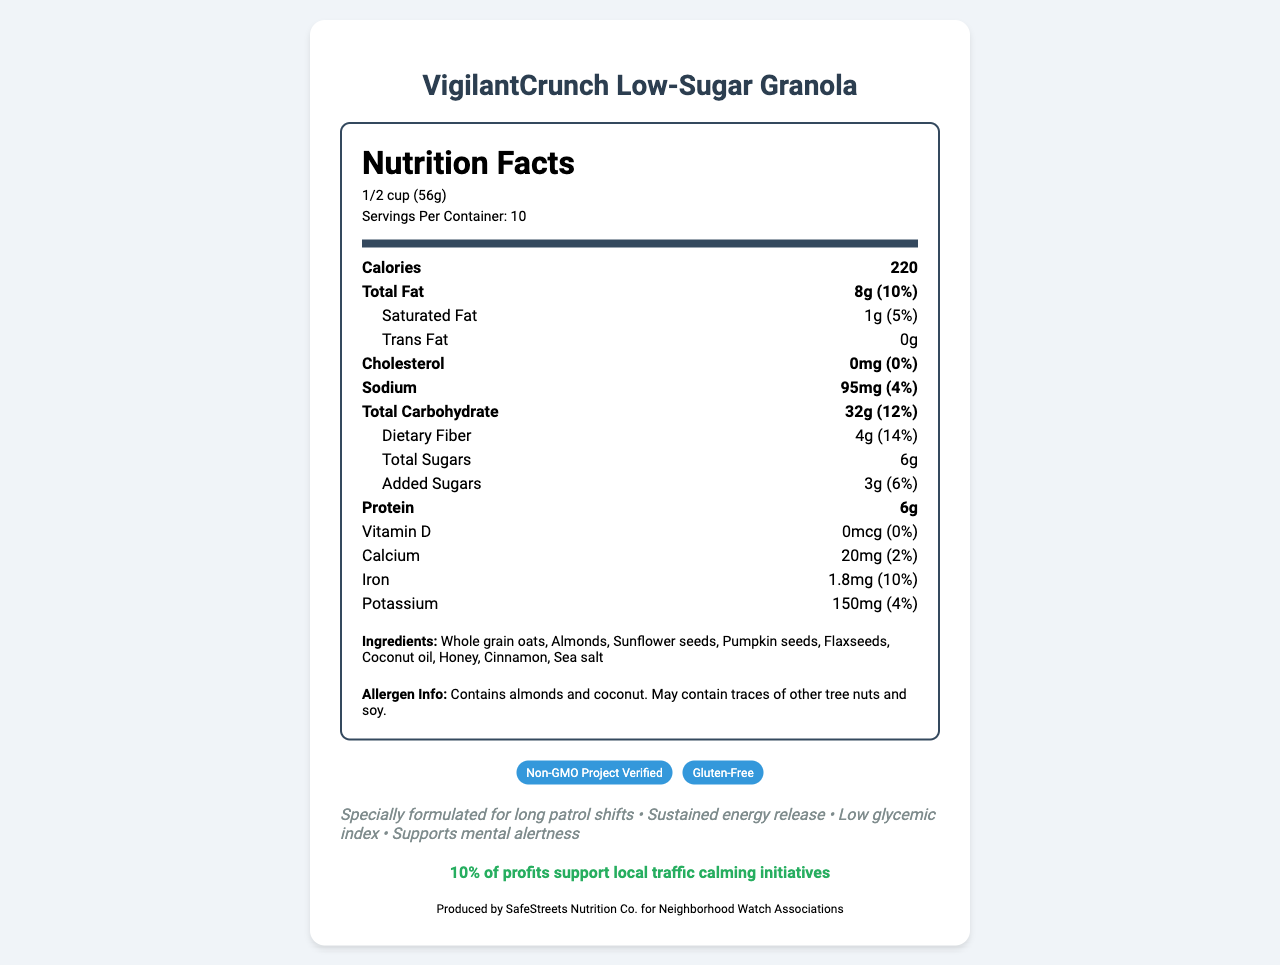what is the serving size? The serving size is listed under the "Nutrition Facts" section with the specification "1/2 cup (56g)".
Answer: 1/2 cup (56g) how many calories are there per serving? The number of calories per serving is clearly shown in the "Nutrition Facts" section as "220".
Answer: 220 calories what is the total fat content and its daily value percentage? The total fat content and its daily value are listed as "8g (10%)" in the "Nutrition Facts" section.
Answer: 8g, 10% how much sugar does the granola contain per serving? The total sugars per serving are listed as "6g", with "3g" being added sugars.
Answer: 6g (3g added sugars) what are the main ingredients in this granola? The ingredients are listed near the end of the document in the "Ingredients" section.
Answer: Whole grain oats, almonds, sunflower seeds, pumpkin seeds, flaxseeds, coconut oil, honey, cinnamon, sea salt is this granola suitable for someone with a soy allergy? The allergen information states that it "May contain traces of other tree nuts and soy."
Answer: No which nutrient has the highest daily value percentage? 
A. Protein 
B. Dietary Fiber 
C. Fat 
D. Sodium The dietary fiber has the highest daily value percentage at 14%, as shown in the "Nutrition Facts" section.
Answer: B how many servings are there per container? 
I. 8 
II. 10 
III. 12 
IV. 14 The servings per container are listed as "10" in the "Nutrition Facts" section.
Answer: II does this product contain any trans fat? The "Nutrition Facts" section lists trans fat as "0g".
Answer: No summarize the main idea of this document. The document details the nutritional facts of VigilantCrunch Low-Sugar Granola, indicating its suitability for long neighborhood watch patrols and other benefits, while also emphasizing the social cause it supports.
Answer: VigilantCrunch Low-Sugar Granola provides specific nutritional details, lists ingredients and allergens, and highlights the benefits for neighborhood patrols with a portion of profits supporting local traffic calming initiatives. what is the impact of buying VigilantCrunch Low-Sugar Granola on local traffic calming initiatives? The document specifies that 10% of profits from this granola will support local traffic calming measures, as highlighted in the "Benefit" section.
Answer: 10% of profits support local traffic calming initiatives does this granola support mental alertness? The marketing claims mention "Supports mental alertness" as one of the benefits.
Answer: Yes who manufactures this granola? The manufacturer information is listed at the end of the document.
Answer: SafeStreets Nutrition Co. for Neighborhood Watch Associations how much iron does a serving of this granola provide? The "Nutrition Facts" section shows that one serving provides "1.8mg (10%)" of iron.
Answer: 1.8mg, 10% daily value what would be the dietary fiber content for consuming one whole container? The dietary fiber per serving is 4g, with 10 servings per container, totaling 40g (140%).
Answer: 40g (140%) is this granola organic? The document provides information on certifications like "Non-GMO Project Verified" and "Gluten-Free" but does not mention organic status.
Answer: Not enough information 